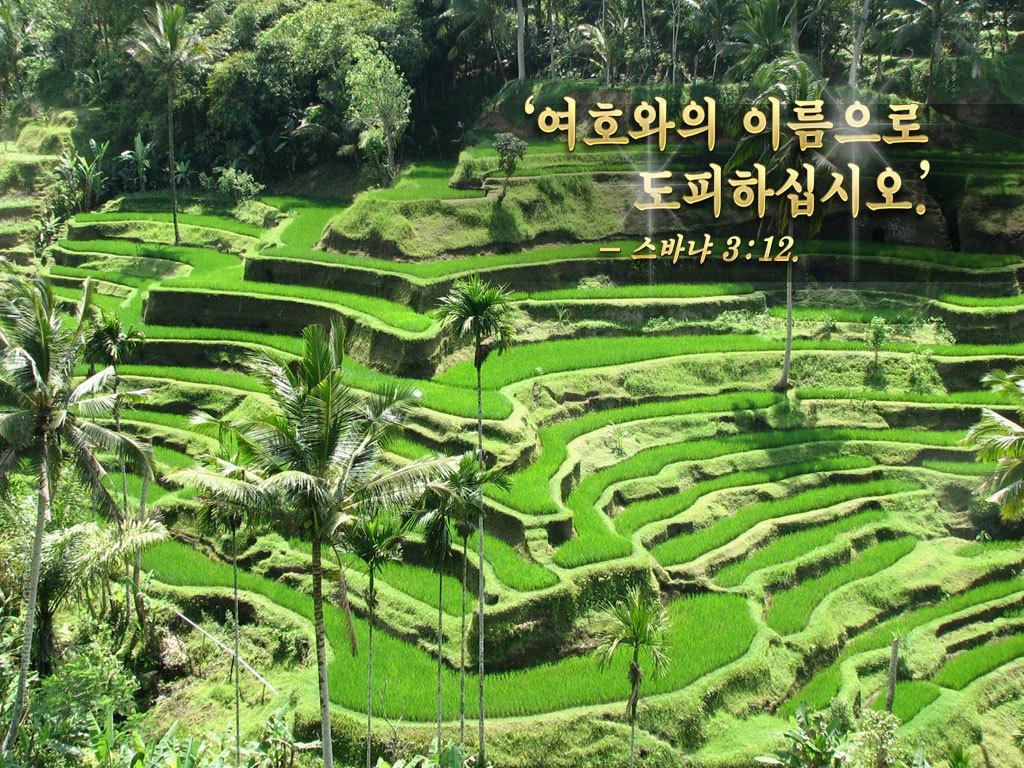Could you give a brief overview of what you see in this image? In the image there are trees and plantation on the valley. 